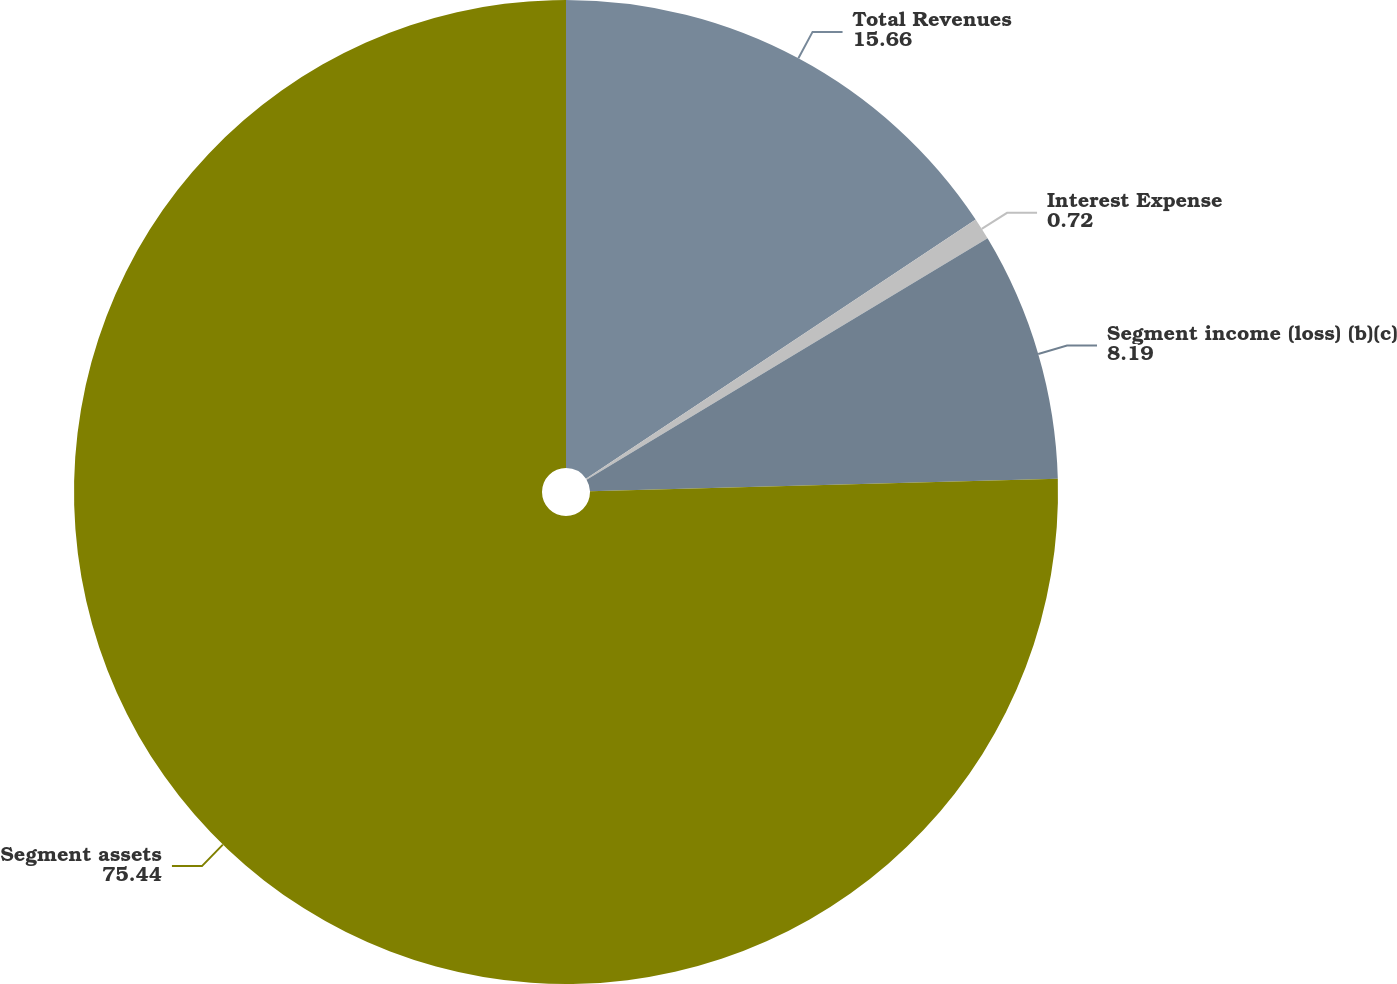Convert chart. <chart><loc_0><loc_0><loc_500><loc_500><pie_chart><fcel>Total Revenues<fcel>Interest Expense<fcel>Segment income (loss) (b)(c)<fcel>Segment assets<nl><fcel>15.66%<fcel>0.72%<fcel>8.19%<fcel>75.44%<nl></chart> 